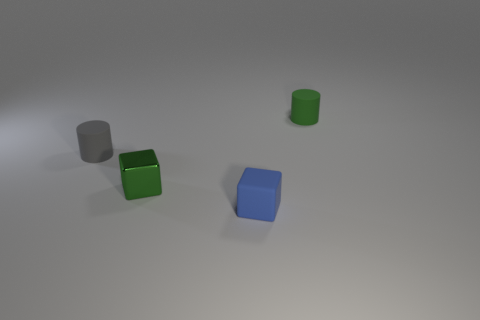Add 4 green rubber cylinders. How many objects exist? 8 Add 1 large red shiny cubes. How many large red shiny cubes exist? 1 Subtract 0 purple cylinders. How many objects are left? 4 Subtract all brown cylinders. Subtract all gray things. How many objects are left? 3 Add 3 small green matte cylinders. How many small green matte cylinders are left? 4 